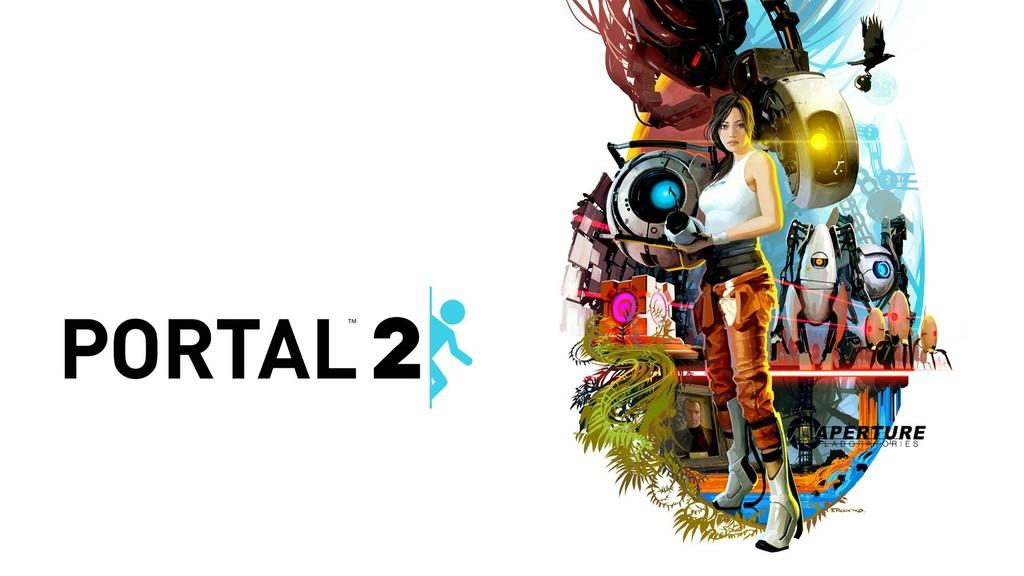What is the main subject of the image? The main subject of the image is a poster. What type of images are on the right side of the poster? There are animated images on the right side of the poster. What is written on the poster? There is text on the left side of the poster. What color is the background of the poster? The background of the poster is white. What time of day is depicted in the image? The image does not depict a specific time of day, as it only features a poster with animated images and text. Can you see a nut in the image? There is no nut present in the image. 